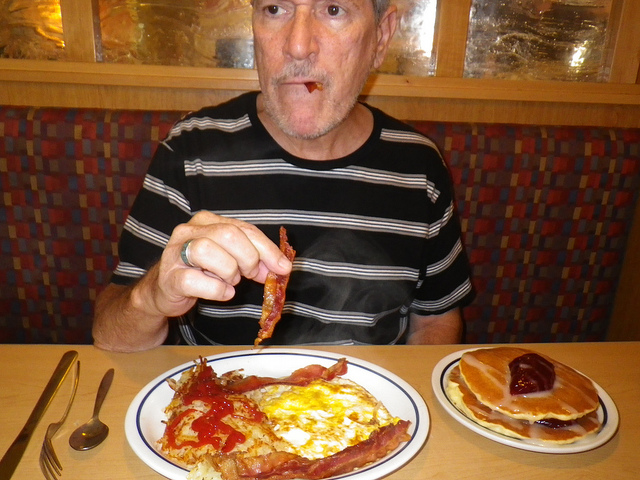<image>What currency was used to purchase this meal? It is unclear what currency was used to purchase this meal. It could be dollars or euros. What currency was used to purchase this meal? I am not sure which currency was used to purchase this meal. It can be either dollars or euros. 